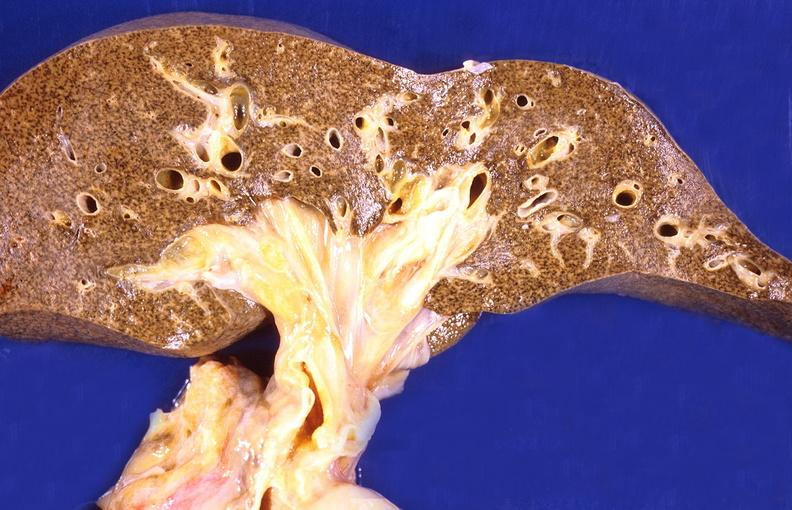s villous adenoma present?
Answer the question using a single word or phrase. No 